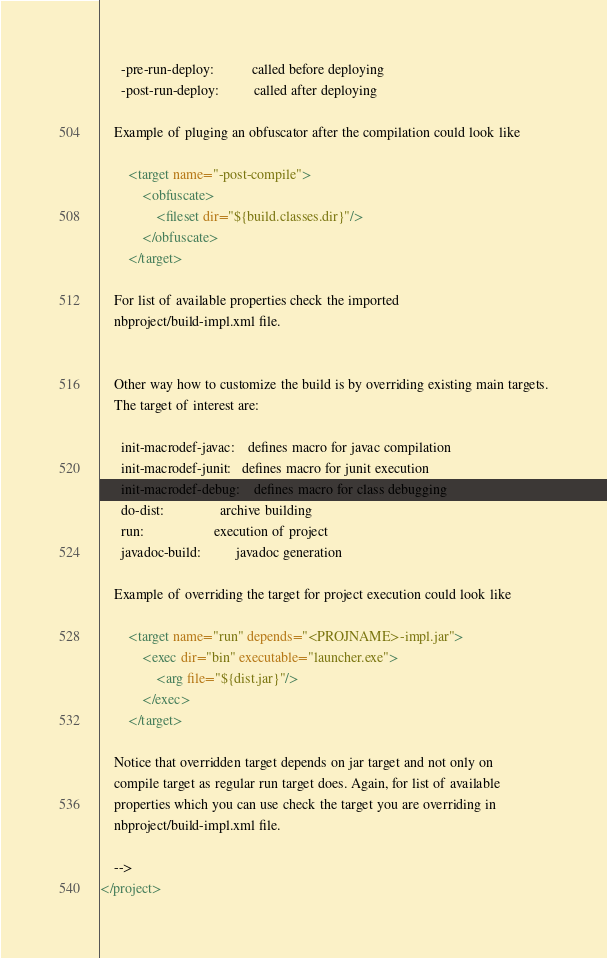Convert code to text. <code><loc_0><loc_0><loc_500><loc_500><_XML_>      -pre-run-deploy:           called before deploying
      -post-run-deploy:          called after deploying

    Example of pluging an obfuscator after the compilation could look like 

        <target name="-post-compile">
            <obfuscate>
                <fileset dir="${build.classes.dir}"/>
            </obfuscate>
        </target>

    For list of available properties check the imported 
    nbproject/build-impl.xml file. 


    Other way how to customize the build is by overriding existing main targets.
    The target of interest are: 

      init-macrodef-javac:    defines macro for javac compilation
      init-macrodef-junit:   defines macro for junit execution
      init-macrodef-debug:    defines macro for class debugging
      do-dist:                archive building
      run:                    execution of project 
      javadoc-build:          javadoc generation 

    Example of overriding the target for project execution could look like 

        <target name="run" depends="<PROJNAME>-impl.jar">
            <exec dir="bin" executable="launcher.exe">
                <arg file="${dist.jar}"/>
            </exec>
        </target>

    Notice that overridden target depends on jar target and not only on 
    compile target as regular run target does. Again, for list of available 
    properties which you can use check the target you are overriding in 
    nbproject/build-impl.xml file. 

    -->
</project>
</code> 